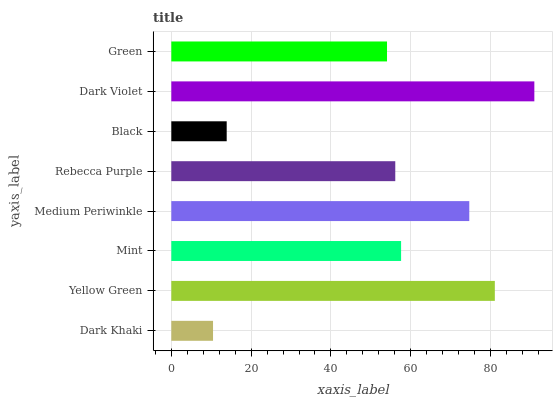Is Dark Khaki the minimum?
Answer yes or no. Yes. Is Dark Violet the maximum?
Answer yes or no. Yes. Is Yellow Green the minimum?
Answer yes or no. No. Is Yellow Green the maximum?
Answer yes or no. No. Is Yellow Green greater than Dark Khaki?
Answer yes or no. Yes. Is Dark Khaki less than Yellow Green?
Answer yes or no. Yes. Is Dark Khaki greater than Yellow Green?
Answer yes or no. No. Is Yellow Green less than Dark Khaki?
Answer yes or no. No. Is Mint the high median?
Answer yes or no. Yes. Is Rebecca Purple the low median?
Answer yes or no. Yes. Is Dark Khaki the high median?
Answer yes or no. No. Is Dark Khaki the low median?
Answer yes or no. No. 